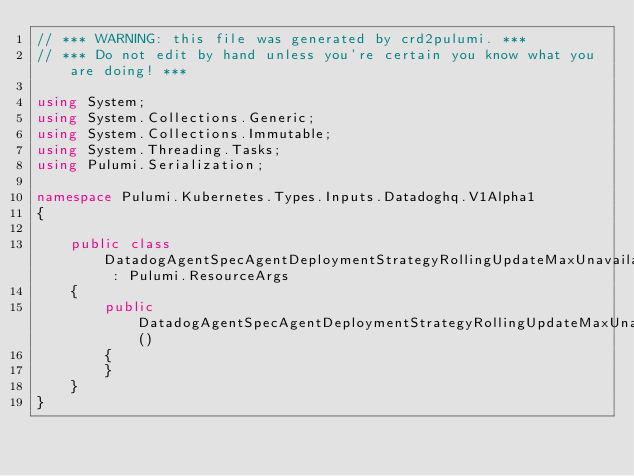<code> <loc_0><loc_0><loc_500><loc_500><_C#_>// *** WARNING: this file was generated by crd2pulumi. ***
// *** Do not edit by hand unless you're certain you know what you are doing! ***

using System;
using System.Collections.Generic;
using System.Collections.Immutable;
using System.Threading.Tasks;
using Pulumi.Serialization;

namespace Pulumi.Kubernetes.Types.Inputs.Datadoghq.V1Alpha1
{

    public class DatadogAgentSpecAgentDeploymentStrategyRollingUpdateMaxUnavailableArgs : Pulumi.ResourceArgs
    {
        public DatadogAgentSpecAgentDeploymentStrategyRollingUpdateMaxUnavailableArgs()
        {
        }
    }
}
</code> 